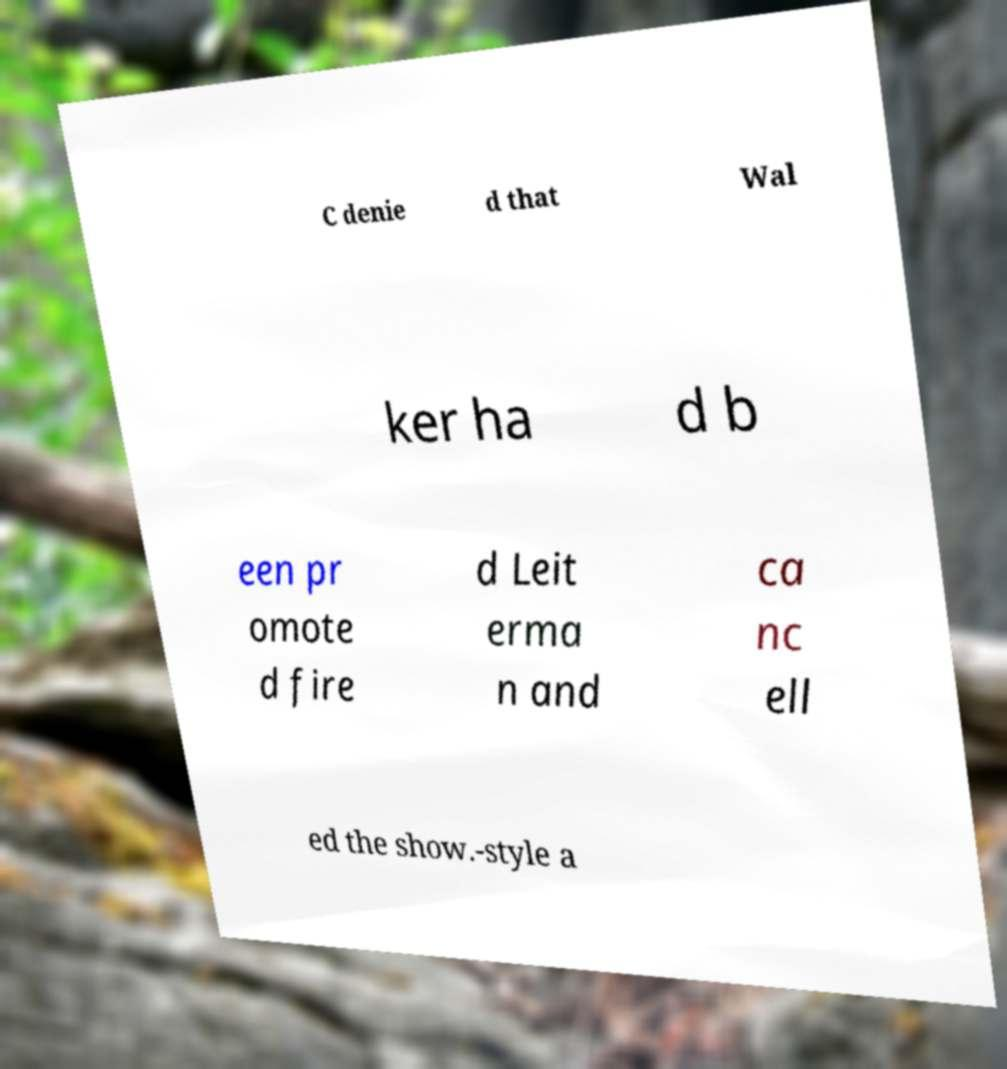Can you accurately transcribe the text from the provided image for me? C denie d that Wal ker ha d b een pr omote d fire d Leit erma n and ca nc ell ed the show.-style a 